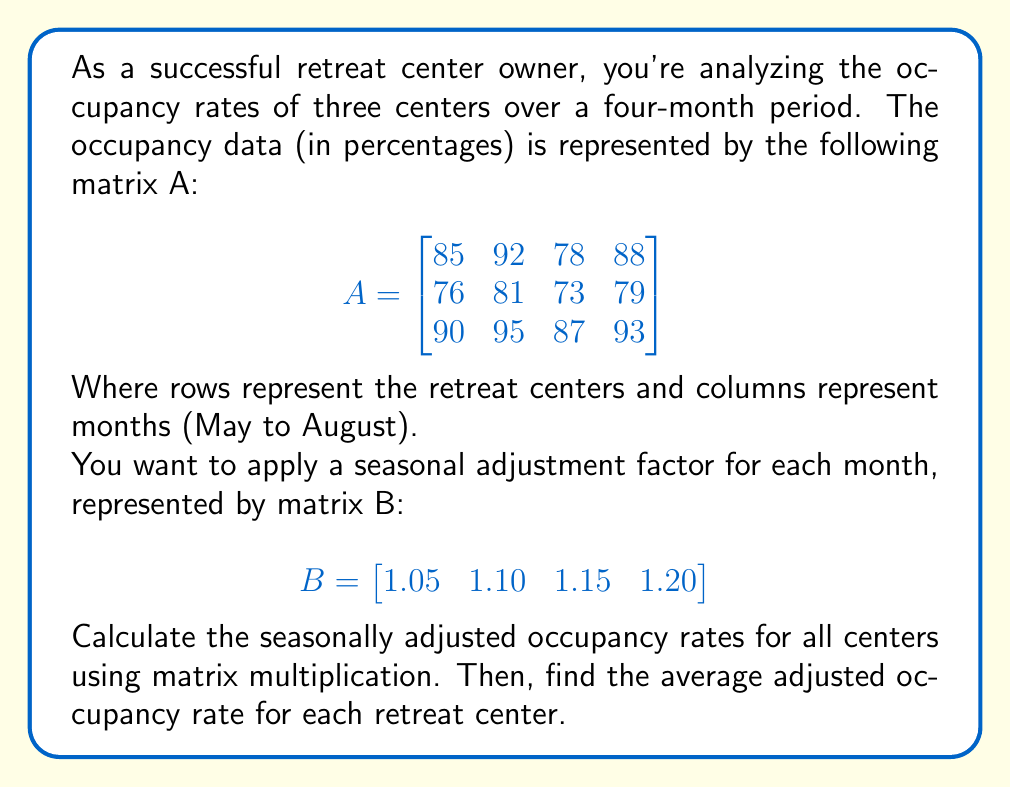Can you solve this math problem? Let's approach this step-by-step:

1) First, we need to multiply matrix A by matrix B. This will give us the seasonally adjusted occupancy rates.

   $$C = A \times B^T$$

   Where $B^T$ is the transpose of B:
   
   $$B^T = \begin{bmatrix}
   1.05 \\
   1.10 \\
   1.15 \\
   1.20
   \end{bmatrix}$$

2) Performing the matrix multiplication:

   $$C = \begin{bmatrix}
   85 & 92 & 78 & 88 \\
   76 & 81 & 73 & 79 \\
   90 & 95 & 87 & 93
   \end{bmatrix} \times 
   \begin{bmatrix}
   1.05 \\
   1.10 \\
   1.15 \\
   1.20
   \end{bmatrix}$$

3) This results in:

   $$C = \begin{bmatrix}
   379.15 \\
   339.90 \\
   401.20
   \end{bmatrix}$$

4) Now, to find the average adjusted occupancy rate for each retreat center, we divide each element of C by 4 (the number of months):

   $$\text{Average} = \begin{bmatrix}
   94.79 \\
   84.98 \\
   100.30
   \end{bmatrix}$$

Thus, the average seasonally adjusted occupancy rates for the three retreat centers are 94.79%, 84.98%, and 100.30% respectively.
Answer: $\begin{bmatrix} 94.79\% \\ 84.98\% \\ 100.30\% \end{bmatrix}$ 